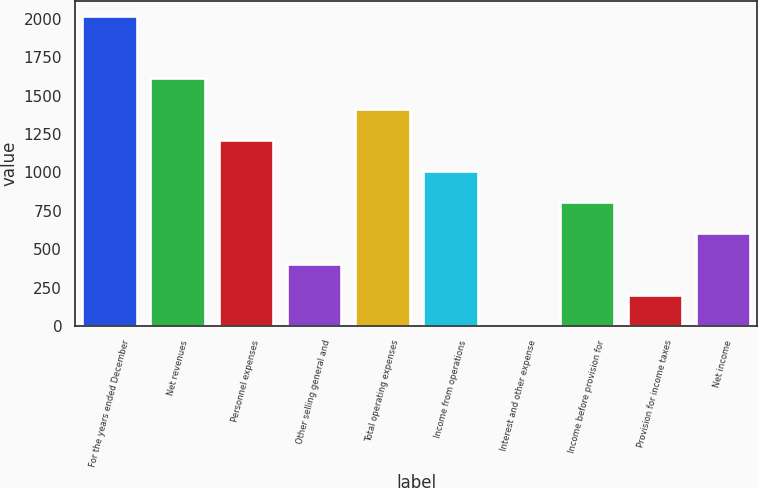<chart> <loc_0><loc_0><loc_500><loc_500><bar_chart><fcel>For the years ended December<fcel>Net revenues<fcel>Personnel expenses<fcel>Other selling general and<fcel>Total operating expenses<fcel>Income from operations<fcel>Interest and other expense<fcel>Income before provision for<fcel>Provision for income taxes<fcel>Net income<nl><fcel>2016<fcel>1613.02<fcel>1210.04<fcel>404.08<fcel>1411.53<fcel>1008.55<fcel>1.1<fcel>807.06<fcel>202.59<fcel>605.57<nl></chart> 